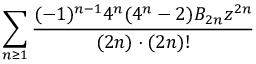Convert formula to latex. <formula><loc_0><loc_0><loc_500><loc_500>\sum _ { n \geq 1 } { \frac { ( - 1 ) ^ { n - 1 } 4 ^ { n } ( 4 ^ { n } - 2 ) B _ { 2 n } z ^ { 2 n } } { ( 2 n ) \cdot ( 2 n ) ! } }</formula> 